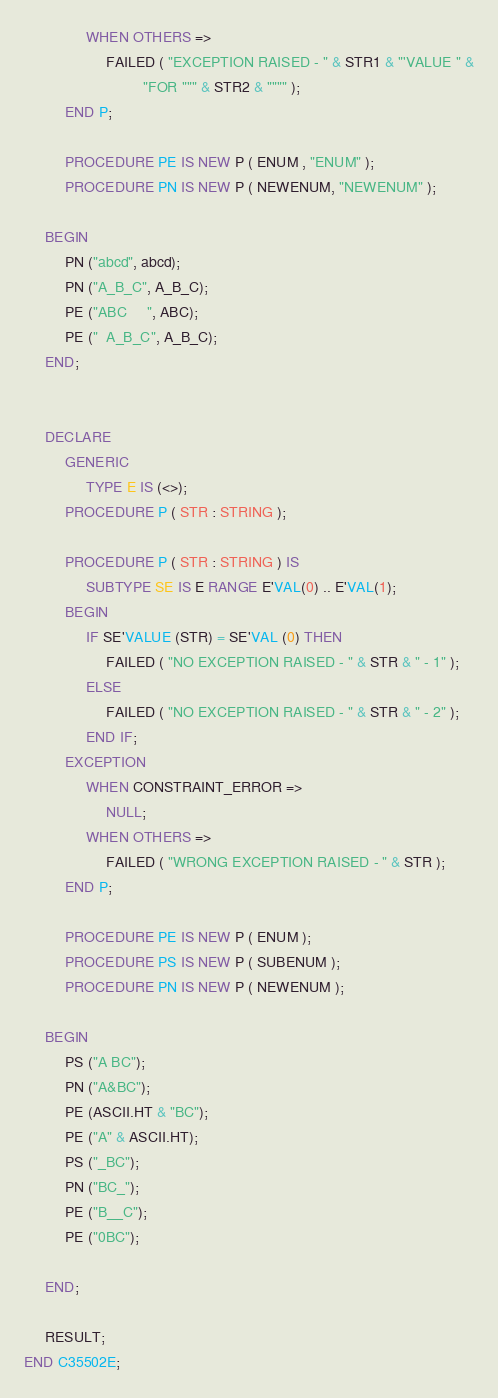<code> <loc_0><loc_0><loc_500><loc_500><_Ada_>               WHEN OTHERS =>
                    FAILED ( "EXCEPTION RAISED - " & STR1 & "'VALUE " &
                             "FOR """ & STR2 & """" );  
          END P;

          PROCEDURE PE IS NEW P ( ENUM , "ENUM" );
          PROCEDURE PN IS NEW P ( NEWENUM, "NEWENUM" );

     BEGIN
          PN ("abcd", abcd);
          PN ("A_B_C", A_B_C);
          PE ("ABC     ", ABC);
          PE ("  A_B_C", A_B_C);
     END;


     DECLARE
          GENERIC
               TYPE E IS (<>);
          PROCEDURE P ( STR : STRING );
          
          PROCEDURE P ( STR : STRING ) IS
               SUBTYPE SE IS E RANGE E'VAL(0) .. E'VAL(1);
          BEGIN
               IF SE'VALUE (STR) = SE'VAL (0) THEN
                    FAILED ( "NO EXCEPTION RAISED - " & STR & " - 1" );
               ELSE
                    FAILED ( "NO EXCEPTION RAISED - " & STR & " - 2" );
               END IF;
          EXCEPTION
               WHEN CONSTRAINT_ERROR =>
                    NULL;
               WHEN OTHERS =>
                    FAILED ( "WRONG EXCEPTION RAISED - " & STR );
          END P;

          PROCEDURE PE IS NEW P ( ENUM );
          PROCEDURE PS IS NEW P ( SUBENUM );
          PROCEDURE PN IS NEW P ( NEWENUM );
          
     BEGIN
          PS ("A BC");
          PN ("A&BC");
          PE (ASCII.HT & "BC");
          PE ("A" & ASCII.HT);
          PS ("_BC");
          PN ("BC_");
          PE ("B__C");
          PE ("0BC");

     END;

     RESULT;
END C35502E;
</code> 